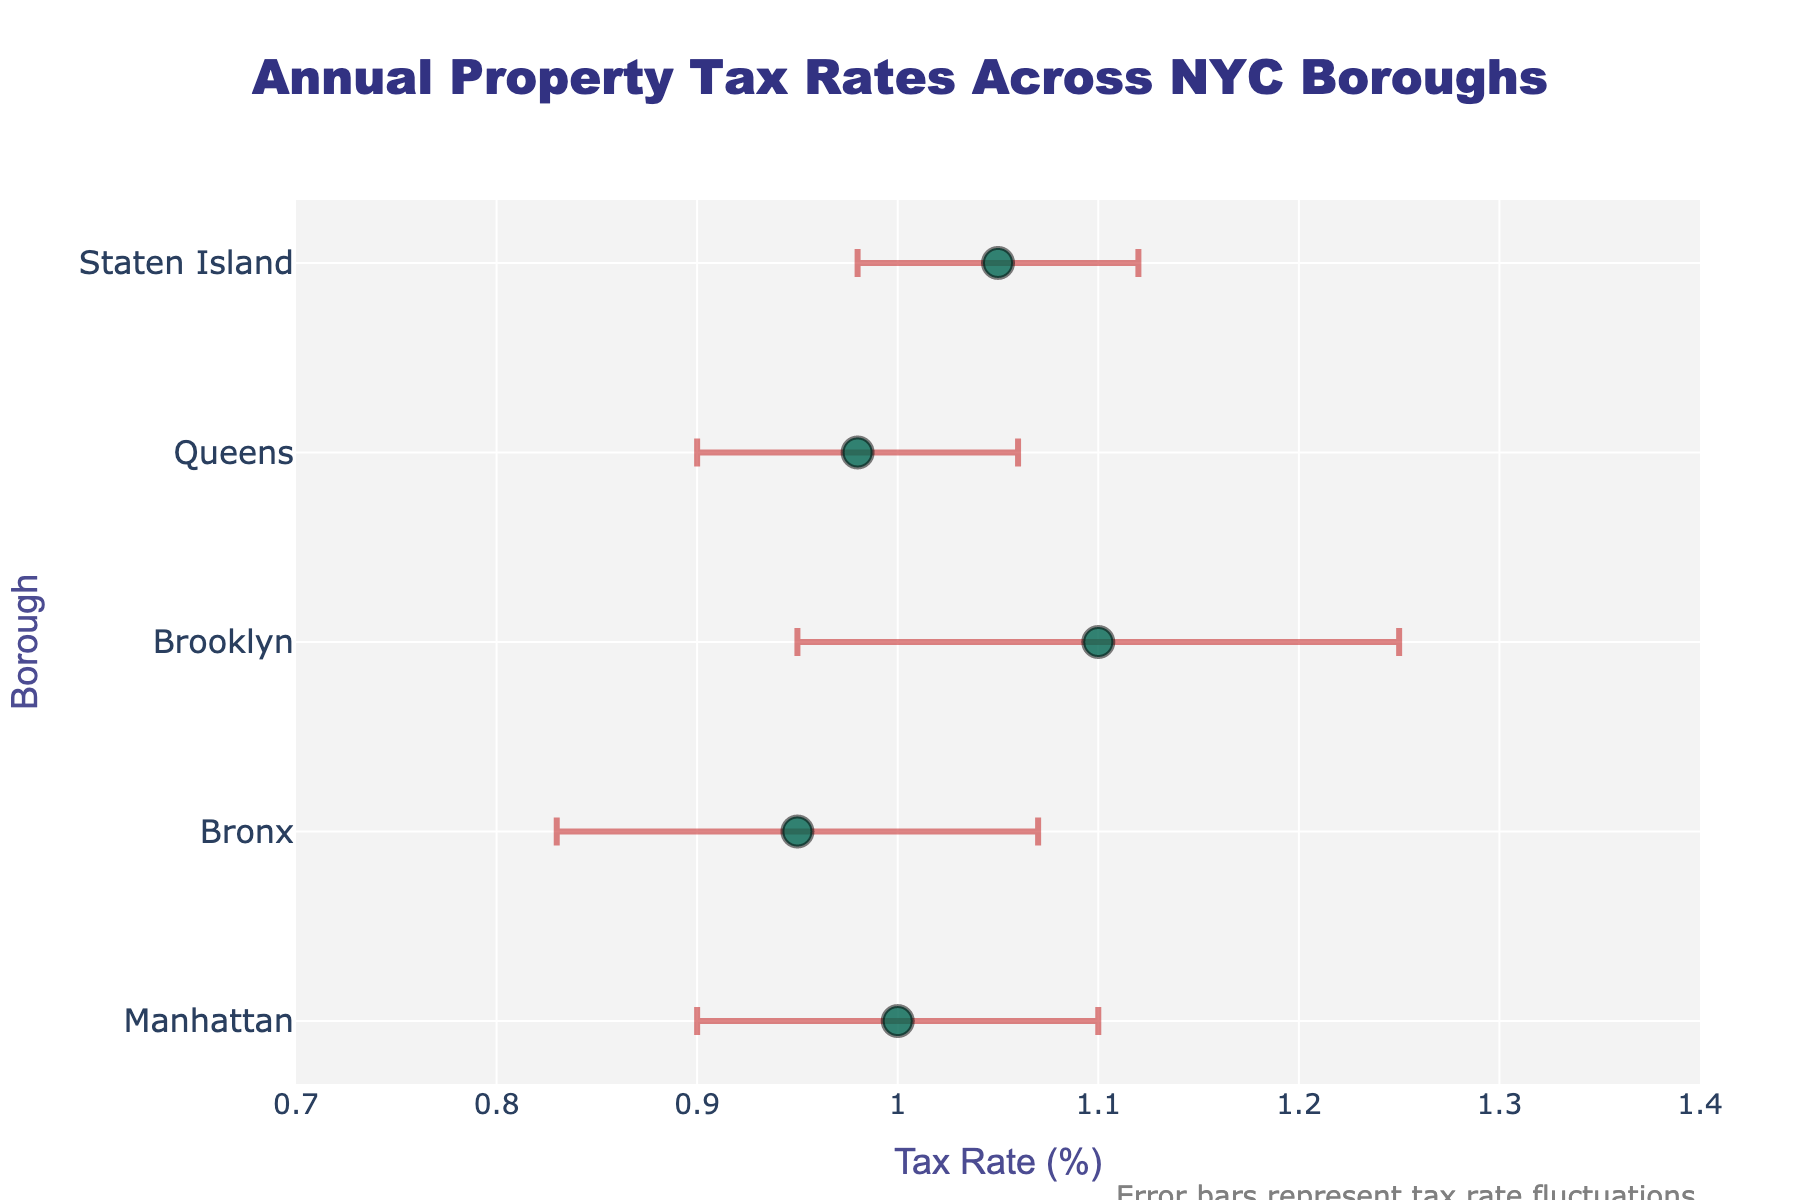what is the title of the figure? The title is usually located at the top of the figure. In this case, the title says "Annual Property Tax Rates Across NYC Boroughs."
Answer: Annual Property Tax Rates Across NYC Boroughs Which borough has the highest mean tax rate? To determine this, look for the dot that is farthest to the right on the x-axis. This dot represents Brooklyn with a mean tax rate of 1.10%.
Answer: Brooklyn What is the range of the x-axis? The x-axis range provides the context for tax rate values. It starts at 0.7% and ends at 1.4%, as indicated in the x-axis settings.
Answer: 0.7% to 1.4% Which borough has the smallest tax rate fluctuation? Tax rate fluctuation is represented by the length of the error bars. The borough with the shortest error bar is Staten Island, which has a standard deviation of 0.07.
Answer: Staten Island What is the difference in mean tax rates between Brooklyn and the Bronx? Subtract the mean tax rate of the Bronx (0.95%) from that of Brooklyn (1.10%): 1.10% - 0.95% = 0.15%.
Answer: 0.15% Which borough has the widest error bar, and what does that imply? The borough with the widest error bar is Brooklyn, indicated by a longer horizontal line. This implies a higher variability or fluctuation in the tax rate for Brooklyn with a standard deviation of 0.15.
Answer: Brooklyn; higher variability Do any boroughs have overlapping error bars in terms of their tax rate fluctuations? Look to see if the range of the error bars for different boroughs intersect. For example, the error bars for Bronx and Brooklyn could potentially overlap due to their large standard deviations.
Answer: Yes, Bronx and Brooklyn How does the mean tax rate for Queens compare to that of Manhattan? The mean tax rate for Queens is 0.98%, and for Manhattan, it is 1.00%. Queens has a slightly lower mean tax rate than Manhattan.
Answer: Queens's rate is lower Approximately, how much higher is the mean tax rate for Brooklyn compared to the average tax rate of all boroughs? First, calculate the average tax rate for all boroughs: (1.00% + 0.95% + 1.10% + 0.98% + 1.05%) / 5 = 1.016%. The difference between Brooklyn's mean tax rate (1.10%) and the average tax rate is 1.10% - 1.016% = 0.084%.
Answer: 0.084% Which borough has a mean tax rate closest to the overall average tax rate? Calculate the average tax rate for all boroughs: (1.00% + 0.95% + 1.10% + 0.98% + 1.05%) / 5 = 1.016%. The borough closest to this value is Manhattan with a mean tax rate of 1.00%.
Answer: Manhattan 